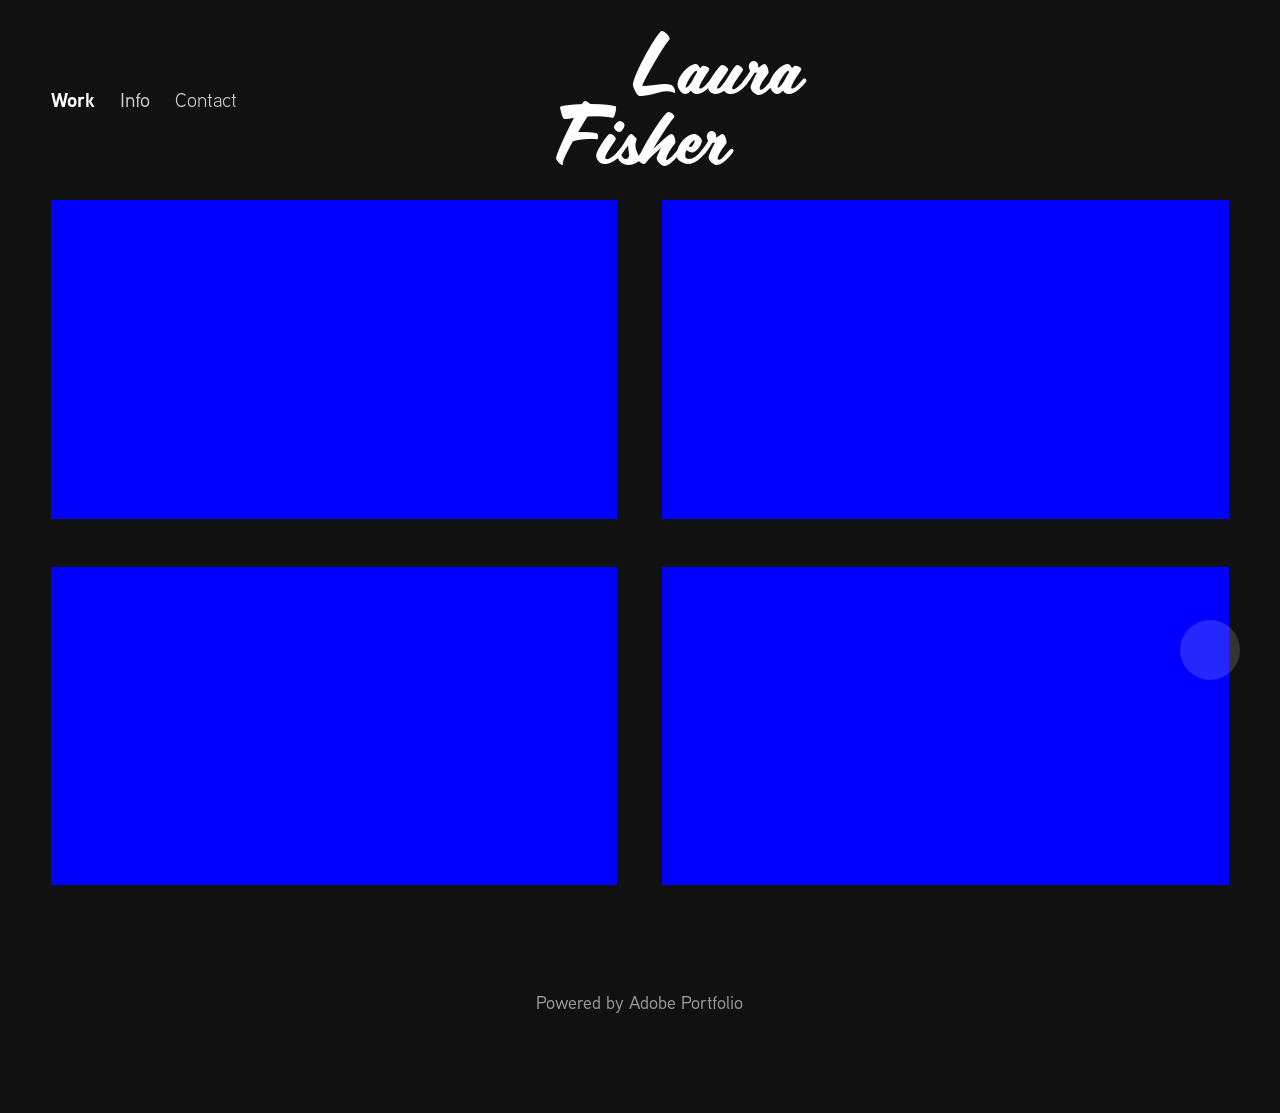How could interactive elements be incorporated to enhance the visual experience of this website? Interactive elements such as hover effects on the gallery images could be added to give a preview of the artwork or its details. Implementing a lightbox feature for viewing full-size images or a slider for sequential artwork would enhance user engagement. Additionally, interactive timelines or filters based on media type or theme could significantly improve user experience, making the site more dynamic and accessible. 